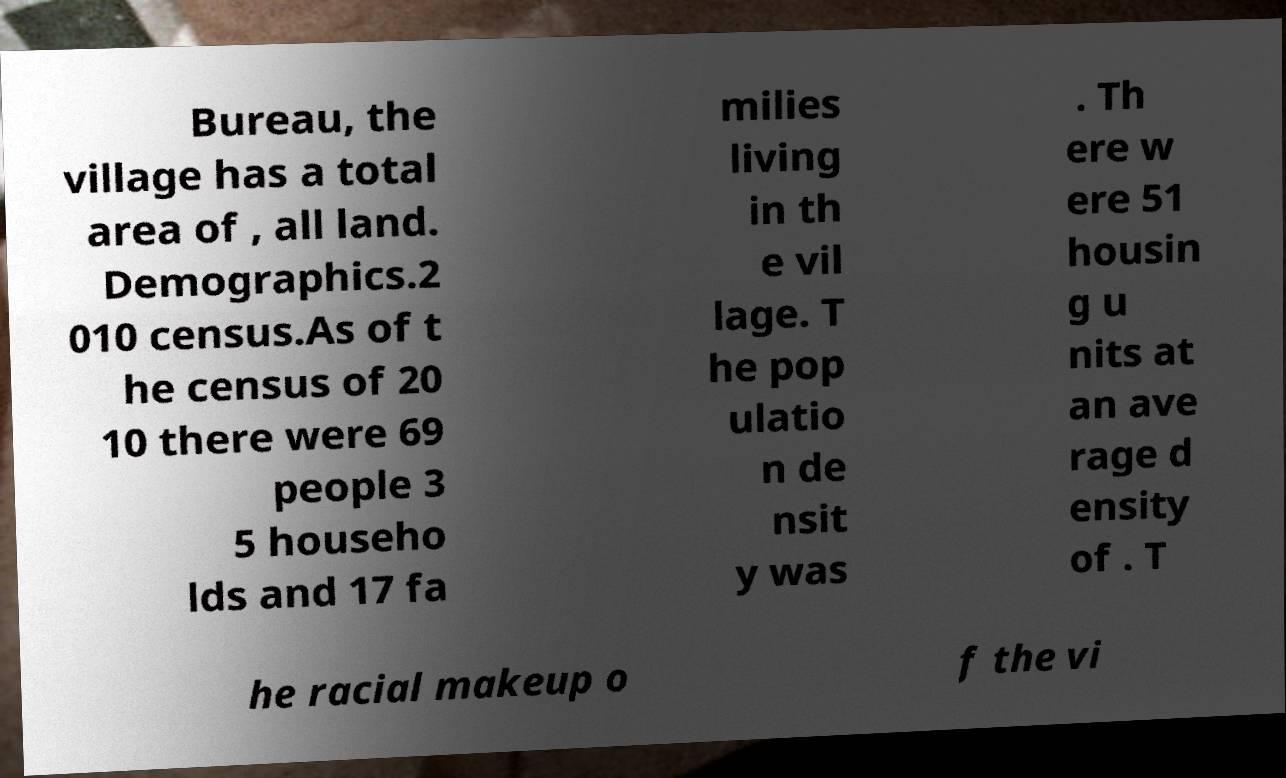Please read and relay the text visible in this image. What does it say? Bureau, the village has a total area of , all land. Demographics.2 010 census.As of t he census of 20 10 there were 69 people 3 5 househo lds and 17 fa milies living in th e vil lage. T he pop ulatio n de nsit y was . Th ere w ere 51 housin g u nits at an ave rage d ensity of . T he racial makeup o f the vi 